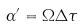<formula> <loc_0><loc_0><loc_500><loc_500>\alpha ^ { \prime } = \Omega \Delta \tau</formula> 